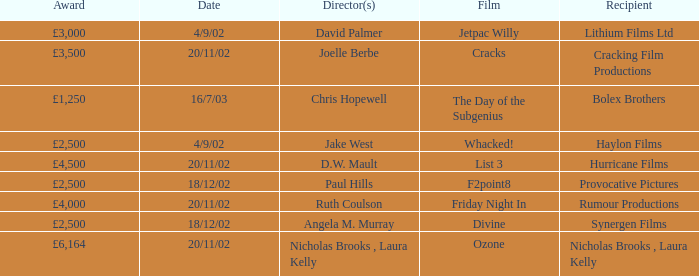What recognition did the ozone film achieve? £6,164. 